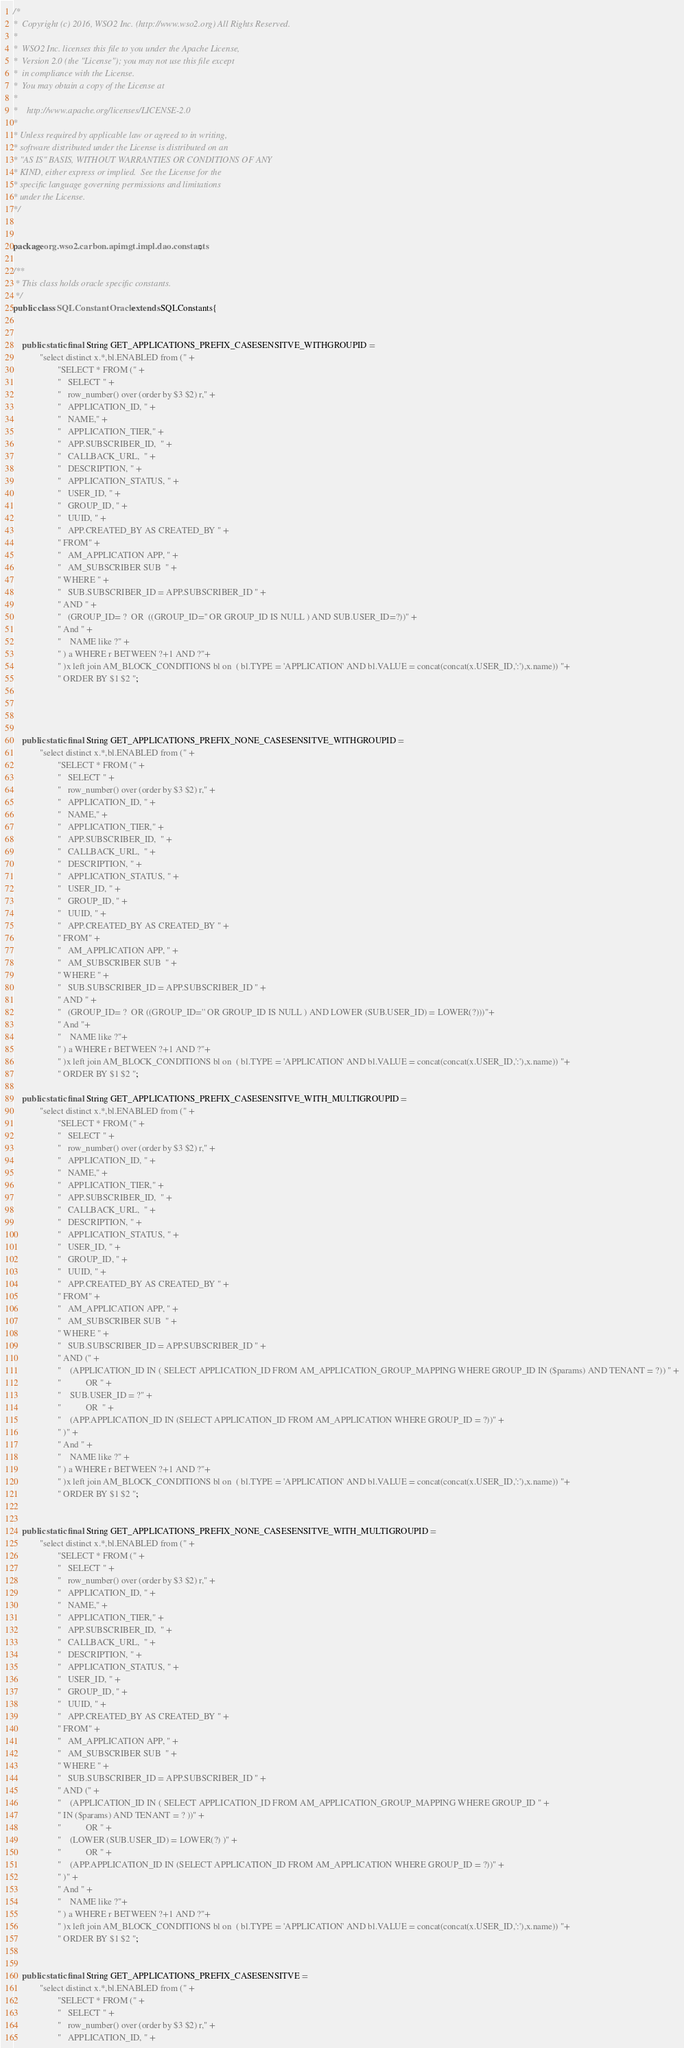Convert code to text. <code><loc_0><loc_0><loc_500><loc_500><_Java_>/*
*  Copyright (c) 2016, WSO2 Inc. (http://www.wso2.org) All Rights Reserved.
*
*  WSO2 Inc. licenses this file to you under the Apache License,
*  Version 2.0 (the "License"); you may not use this file except
*  in compliance with the License.
*  You may obtain a copy of the License at
*
*    http://www.apache.org/licenses/LICENSE-2.0
*
* Unless required by applicable law or agreed to in writing,
* software distributed under the License is distributed on an
* "AS IS" BASIS, WITHOUT WARRANTIES OR CONDITIONS OF ANY
* KIND, either express or implied.  See the License for the
* specific language governing permissions and limitations
* under the License.
*/


package org.wso2.carbon.apimgt.impl.dao.constants;

/**
 * This class holds oracle specific constants.
 */
public class SQLConstantOracle extends SQLConstants{


    public static final String GET_APPLICATIONS_PREFIX_CASESENSITVE_WITHGROUPID =
            "select distinct x.*,bl.ENABLED from (" +
                    "SELECT * FROM (" +
                    "   SELECT " +
                    "   row_number() over (order by $3 $2) r," +
                    "   APPLICATION_ID, " +
                    "   NAME," +
                    "   APPLICATION_TIER," +
                    "   APP.SUBSCRIBER_ID,  " +
                    "   CALLBACK_URL,  " +
                    "   DESCRIPTION, " +
                    "   APPLICATION_STATUS, " +
                    "   USER_ID, " +
                    "   GROUP_ID, " +
                    "   UUID, " +
                    "   APP.CREATED_BY AS CREATED_BY " +
                    " FROM" +
                    "   AM_APPLICATION APP, " +
                    "   AM_SUBSCRIBER SUB  " +
                    " WHERE " +
                    "   SUB.SUBSCRIBER_ID = APP.SUBSCRIBER_ID " +
                    " AND " +
                    "   (GROUP_ID= ?  OR  ((GROUP_ID='' OR GROUP_ID IS NULL ) AND SUB.USER_ID=?))" +
                    " And " +
                    "    NAME like ?" +
                    " ) a WHERE r BETWEEN ?+1 AND ?"+
                    " )x left join AM_BLOCK_CONDITIONS bl on  ( bl.TYPE = 'APPLICATION' AND bl.VALUE = concat(concat(x.USER_ID,':'),x.name)) "+
                    " ORDER BY $1 $2 ";




    public static final String GET_APPLICATIONS_PREFIX_NONE_CASESENSITVE_WITHGROUPID =
            "select distinct x.*,bl.ENABLED from (" +
                    "SELECT * FROM (" +
                    "   SELECT " +
                    "   row_number() over (order by $3 $2) r," +
                    "   APPLICATION_ID, " +
                    "   NAME," +
                    "   APPLICATION_TIER," +
                    "   APP.SUBSCRIBER_ID,  " +
                    "   CALLBACK_URL,  " +
                    "   DESCRIPTION, " +
                    "   APPLICATION_STATUS, " +
                    "   USER_ID, " +
                    "   GROUP_ID, " +
                    "   UUID, " +
                    "   APP.CREATED_BY AS CREATED_BY " +
                    " FROM" +
                    "   AM_APPLICATION APP, " +
                    "   AM_SUBSCRIBER SUB  " +
                    " WHERE " +
                    "   SUB.SUBSCRIBER_ID = APP.SUBSCRIBER_ID " +
                    " AND " +
                    "   (GROUP_ID= ?  OR ((GROUP_ID='' OR GROUP_ID IS NULL ) AND LOWER (SUB.USER_ID) = LOWER(?)))"+
                    " And "+
                    "    NAME like ?"+
                    " ) a WHERE r BETWEEN ?+1 AND ?"+
                    " )x left join AM_BLOCK_CONDITIONS bl on  ( bl.TYPE = 'APPLICATION' AND bl.VALUE = concat(concat(x.USER_ID,':'),x.name)) "+
                    " ORDER BY $1 $2 ";

    public static final String GET_APPLICATIONS_PREFIX_CASESENSITVE_WITH_MULTIGROUPID =
            "select distinct x.*,bl.ENABLED from (" +
                    "SELECT * FROM (" +
                    "   SELECT " +
                    "   row_number() over (order by $3 $2) r," +
                    "   APPLICATION_ID, " +
                    "   NAME," +
                    "   APPLICATION_TIER," +
                    "   APP.SUBSCRIBER_ID,  " +
                    "   CALLBACK_URL,  " +
                    "   DESCRIPTION, " +
                    "   APPLICATION_STATUS, " +
                    "   USER_ID, " +
                    "   GROUP_ID, " +
                    "   UUID, " +
                    "   APP.CREATED_BY AS CREATED_BY " +
                    " FROM" +
                    "   AM_APPLICATION APP, " +
                    "   AM_SUBSCRIBER SUB  " +
                    " WHERE " +
                    "   SUB.SUBSCRIBER_ID = APP.SUBSCRIBER_ID " +
                    " AND (" +
                    "    (APPLICATION_ID IN ( SELECT APPLICATION_ID FROM AM_APPLICATION_GROUP_MAPPING WHERE GROUP_ID IN ($params) AND TENANT = ?)) " +
                    "           OR " +
                    "    SUB.USER_ID = ?" +
                    "           OR  " +
                    "    (APP.APPLICATION_ID IN (SELECT APPLICATION_ID FROM AM_APPLICATION WHERE GROUP_ID = ?))" +
                    " )" +
                    " And " +
                    "    NAME like ?" +
                    " ) a WHERE r BETWEEN ?+1 AND ?"+
                    " )x left join AM_BLOCK_CONDITIONS bl on  ( bl.TYPE = 'APPLICATION' AND bl.VALUE = concat(concat(x.USER_ID,':'),x.name)) "+
                    " ORDER BY $1 $2 ";


    public static final String GET_APPLICATIONS_PREFIX_NONE_CASESENSITVE_WITH_MULTIGROUPID =
            "select distinct x.*,bl.ENABLED from (" +
                    "SELECT * FROM (" +
                    "   SELECT " +
                    "   row_number() over (order by $3 $2) r," +
                    "   APPLICATION_ID, " +
                    "   NAME," +
                    "   APPLICATION_TIER," +
                    "   APP.SUBSCRIBER_ID,  " +
                    "   CALLBACK_URL,  " +
                    "   DESCRIPTION, " +
                    "   APPLICATION_STATUS, " +
                    "   USER_ID, " +
                    "   GROUP_ID, " +
                    "   UUID, " +
                    "   APP.CREATED_BY AS CREATED_BY " +
                    " FROM" +
                    "   AM_APPLICATION APP, " +
                    "   AM_SUBSCRIBER SUB  " +
                    " WHERE " +
                    "   SUB.SUBSCRIBER_ID = APP.SUBSCRIBER_ID " +
                    " AND (" +
                    "    (APPLICATION_ID IN ( SELECT APPLICATION_ID FROM AM_APPLICATION_GROUP_MAPPING WHERE GROUP_ID " +
                    " IN ($params) AND TENANT = ? ))" +
                    "           OR " +
                    "    (LOWER (SUB.USER_ID) = LOWER(?) )" +
                    "           OR " +
                    "    (APP.APPLICATION_ID IN (SELECT APPLICATION_ID FROM AM_APPLICATION WHERE GROUP_ID = ?))" +
                    " )" +
                    " And " +
                    "    NAME like ?"+
                    " ) a WHERE r BETWEEN ?+1 AND ?"+
                    " )x left join AM_BLOCK_CONDITIONS bl on  ( bl.TYPE = 'APPLICATION' AND bl.VALUE = concat(concat(x.USER_ID,':'),x.name)) "+
                    " ORDER BY $1 $2 ";


    public static final String GET_APPLICATIONS_PREFIX_CASESENSITVE =
            "select distinct x.*,bl.ENABLED from (" +
                    "SELECT * FROM (" +
                    "   SELECT " +
                    "   row_number() over (order by $3 $2) r," +
                    "   APPLICATION_ID, " +</code> 